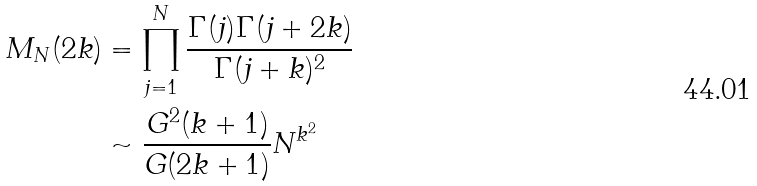<formula> <loc_0><loc_0><loc_500><loc_500>M _ { N } ( 2 k ) & = \prod _ { j = 1 } ^ { N } \frac { \Gamma ( j ) \Gamma ( j + 2 k ) } { \Gamma ( j + k ) ^ { 2 } } \\ & \sim \frac { G ^ { 2 } ( k + 1 ) } { G ( 2 k + 1 ) } N ^ { k ^ { 2 } }</formula> 